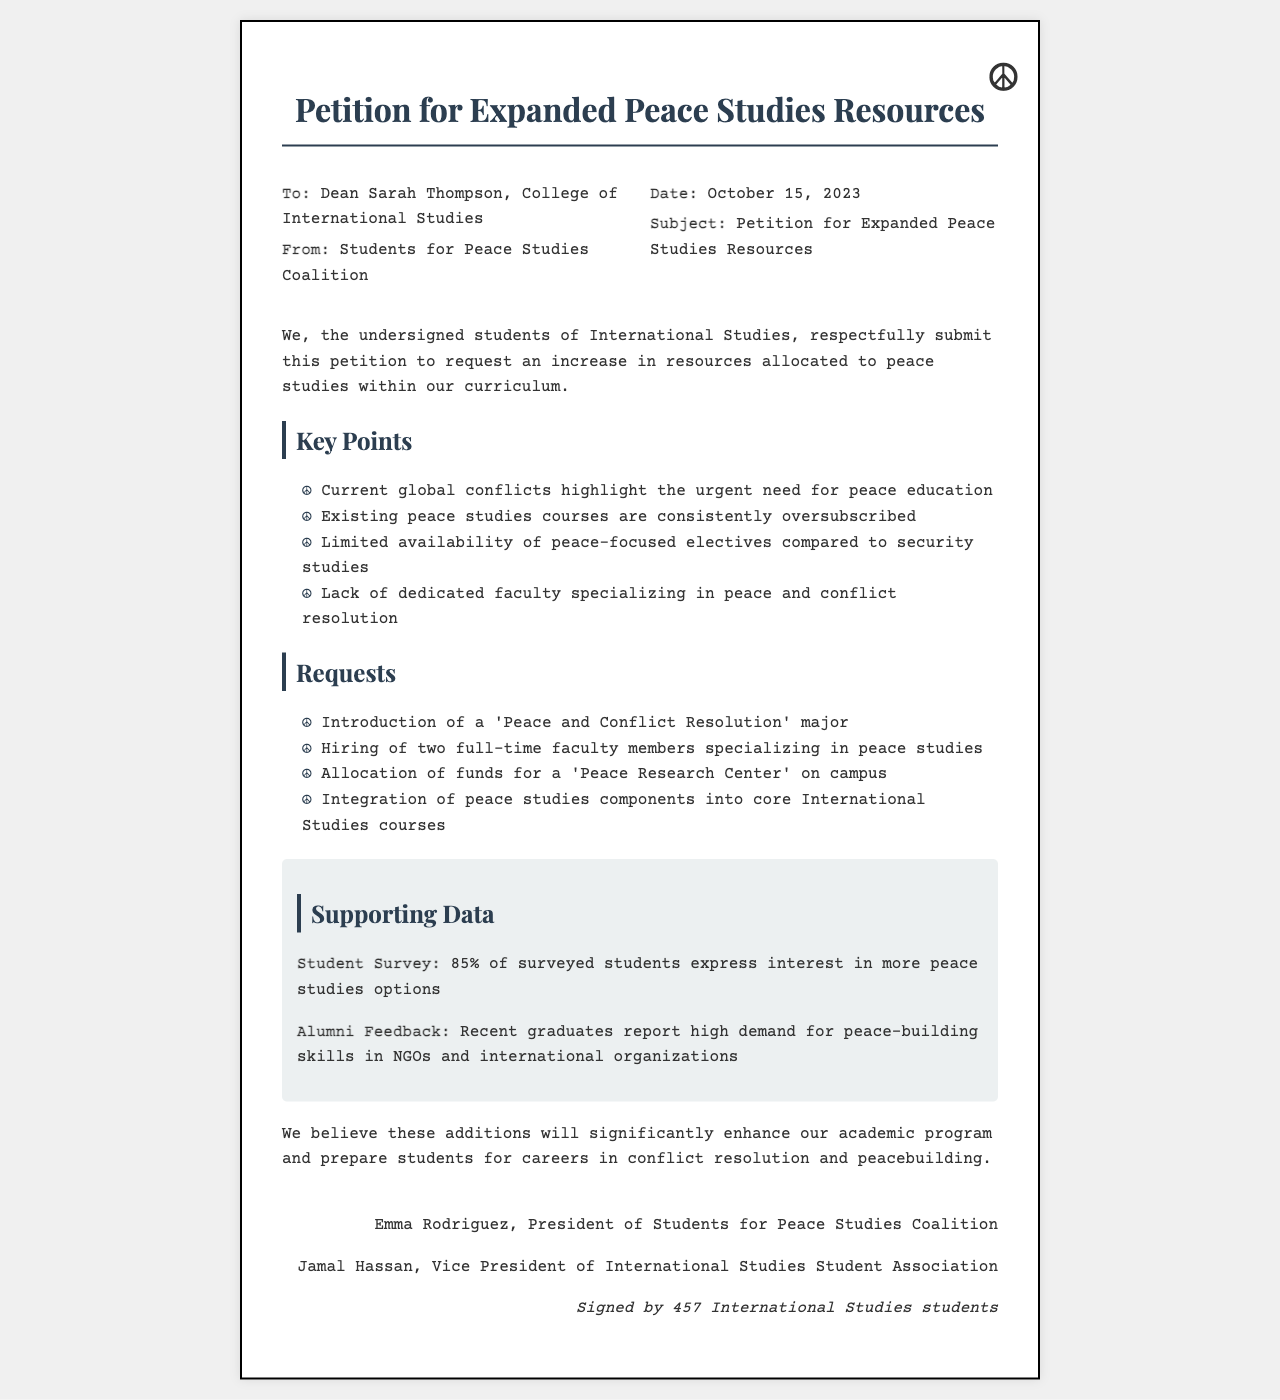What is the title of the petition? The title is stated at the top of the document as "Petition for Expanded Peace Studies Resources."
Answer: Petition for Expanded Peace Studies Resources Who is the petition addressed to? The document specifies the recipient of the petition as "Dean Sarah Thompson, College of International Studies."
Answer: Dean Sarah Thompson What percentage of surveyed students expressed interest in more peace studies options? The document states that "85% of surveyed students express interest in more peace studies options."
Answer: 85% How many full-time faculty members are requested to be hired? The petition requests the hiring of "two full-time faculty members specializing in peace studies."
Answer: two What is the date of the petition? The document includes a date, which is "October 15, 2023."
Answer: October 15, 2023 How many students signed the petition? The document concludes with the note that "Signed by 457 International Studies students."
Answer: 457 What is one of the key points mentioned in the petition? The petition lists key points, one being "Current global conflicts highlight the urgent need for peace education."
Answer: Current global conflicts highlight the urgent need for peace education What major is proposed in the requests section? The document requests the introduction of a "Peace and Conflict Resolution" major.
Answer: Peace and Conflict Resolution What organization is the sender of the petition? The document identifies the sender as "Students for Peace Studies Coalition."
Answer: Students for Peace Studies Coalition 